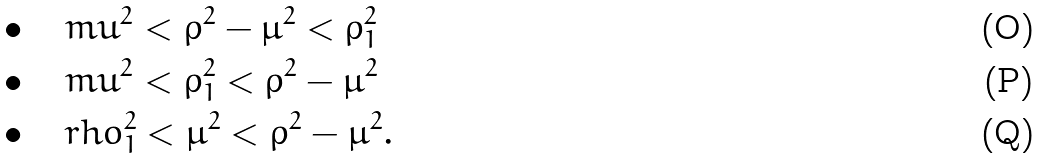<formula> <loc_0><loc_0><loc_500><loc_500>& \bullet \quad m u ^ { 2 } < \rho ^ { 2 } - \mu ^ { 2 } < \rho _ { 1 } ^ { 2 } \\ & \bullet \quad m u ^ { 2 } < \rho _ { 1 } ^ { 2 } < \rho ^ { 2 } - \mu ^ { 2 } \\ & \bullet \quad r h o _ { 1 } ^ { 2 } < \mu ^ { 2 } < \rho ^ { 2 } - \mu ^ { 2 } .</formula> 